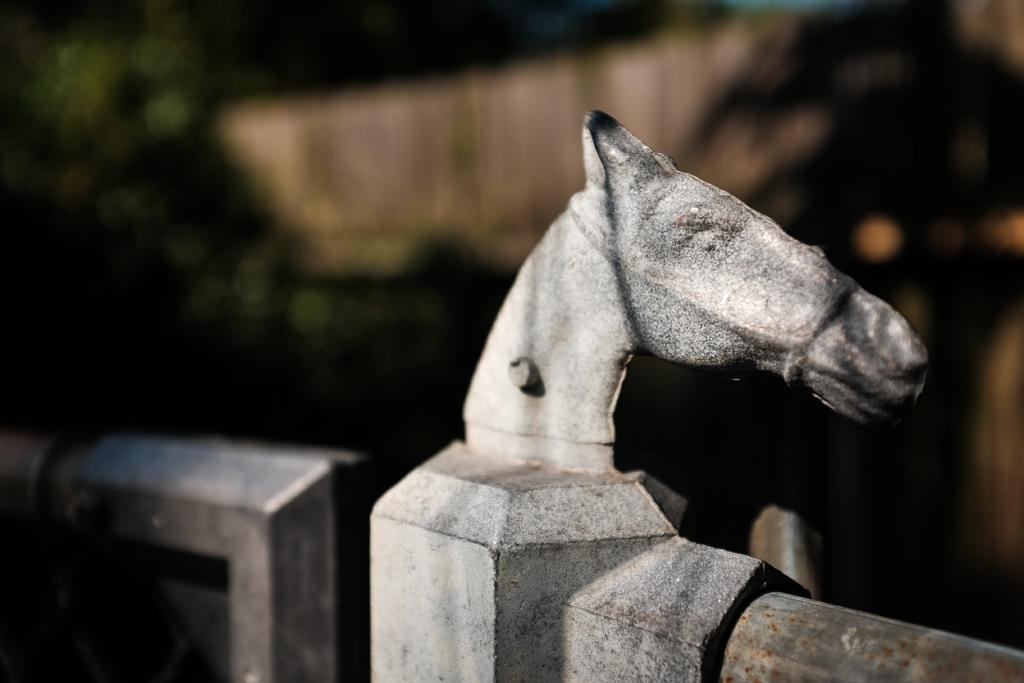What is depicted on the wall in the image? There is a sculpture on the wall in the image. Can you describe the subject of the sculpture? The sculpture is the head of a horse. What can be observed about the background of the image? The background of the image is blurry. Reasoning: Let's think step by following the guidelines to produce the conversation. We start by identifying the main subject in the image, which is the sculpture on the wall. Then, we describe the specific details of the sculpture, mentioning that it is the head of a horse. Finally, we address the background of the image, noting that it is blurry. Absurd Question/Answer: Is there a crown placed on the horse's head in the sculpture? There is no crown visible on the horse's head in the sculpture; it only depicts the head of a horse. 